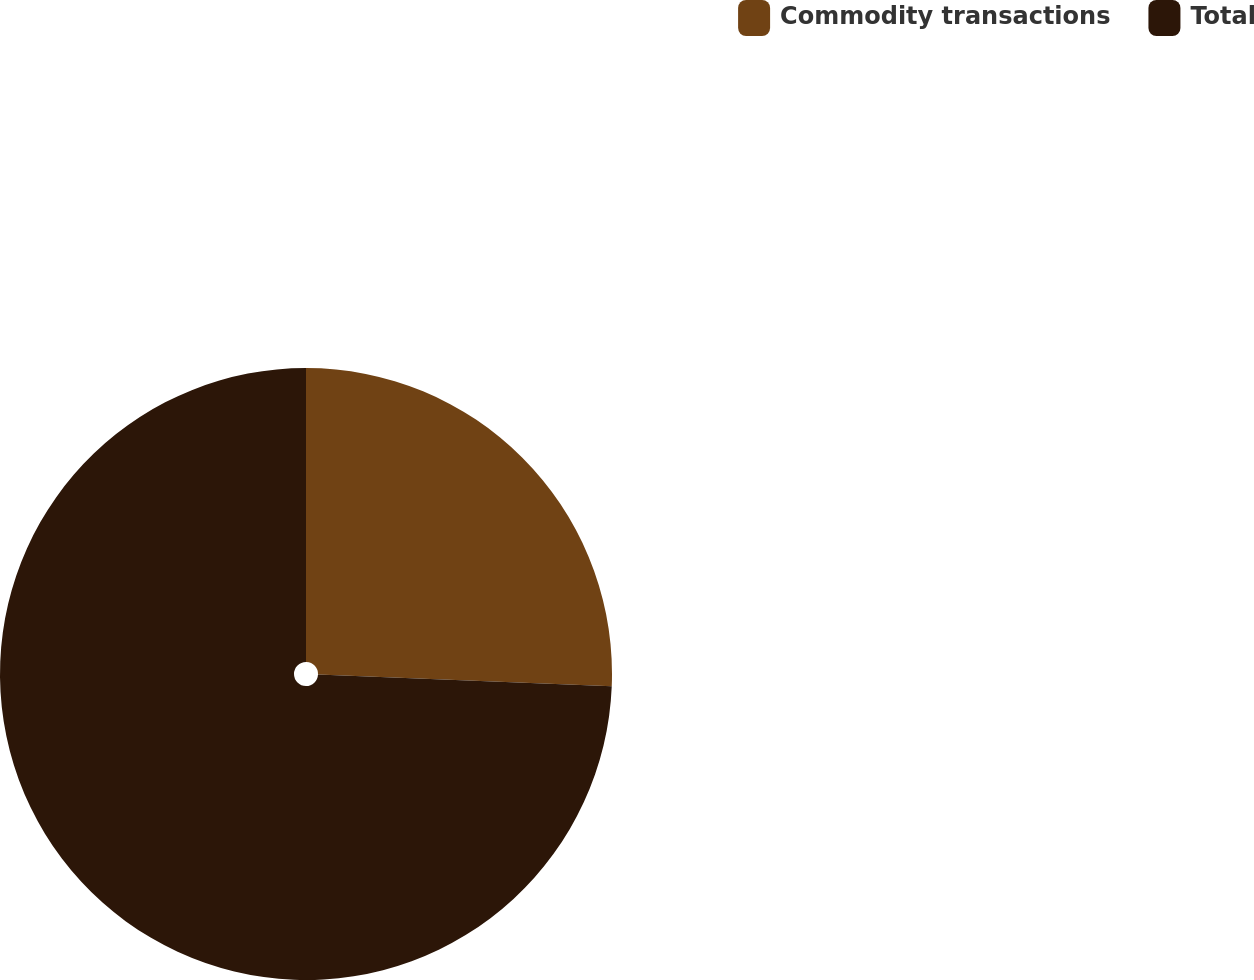Convert chart to OTSL. <chart><loc_0><loc_0><loc_500><loc_500><pie_chart><fcel>Commodity transactions<fcel>Total<nl><fcel>25.64%<fcel>74.36%<nl></chart> 